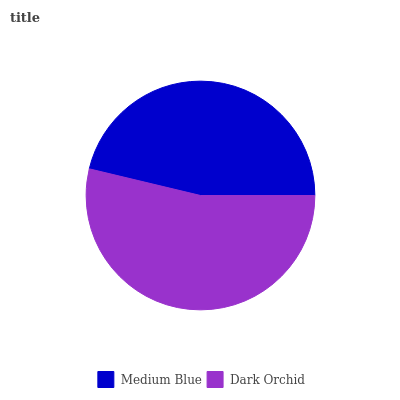Is Medium Blue the minimum?
Answer yes or no. Yes. Is Dark Orchid the maximum?
Answer yes or no. Yes. Is Dark Orchid the minimum?
Answer yes or no. No. Is Dark Orchid greater than Medium Blue?
Answer yes or no. Yes. Is Medium Blue less than Dark Orchid?
Answer yes or no. Yes. Is Medium Blue greater than Dark Orchid?
Answer yes or no. No. Is Dark Orchid less than Medium Blue?
Answer yes or no. No. Is Dark Orchid the high median?
Answer yes or no. Yes. Is Medium Blue the low median?
Answer yes or no. Yes. Is Medium Blue the high median?
Answer yes or no. No. Is Dark Orchid the low median?
Answer yes or no. No. 